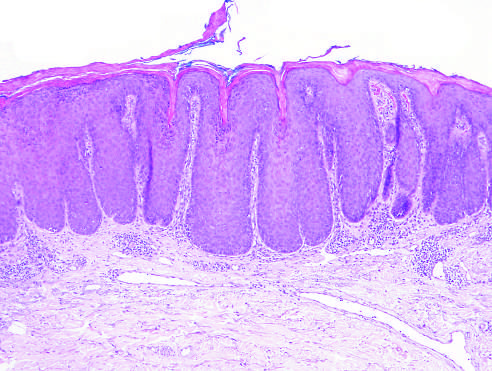what are present?
Answer the question using a single word or phrase. Superficial dermal fibrosis and vascular ectasia 